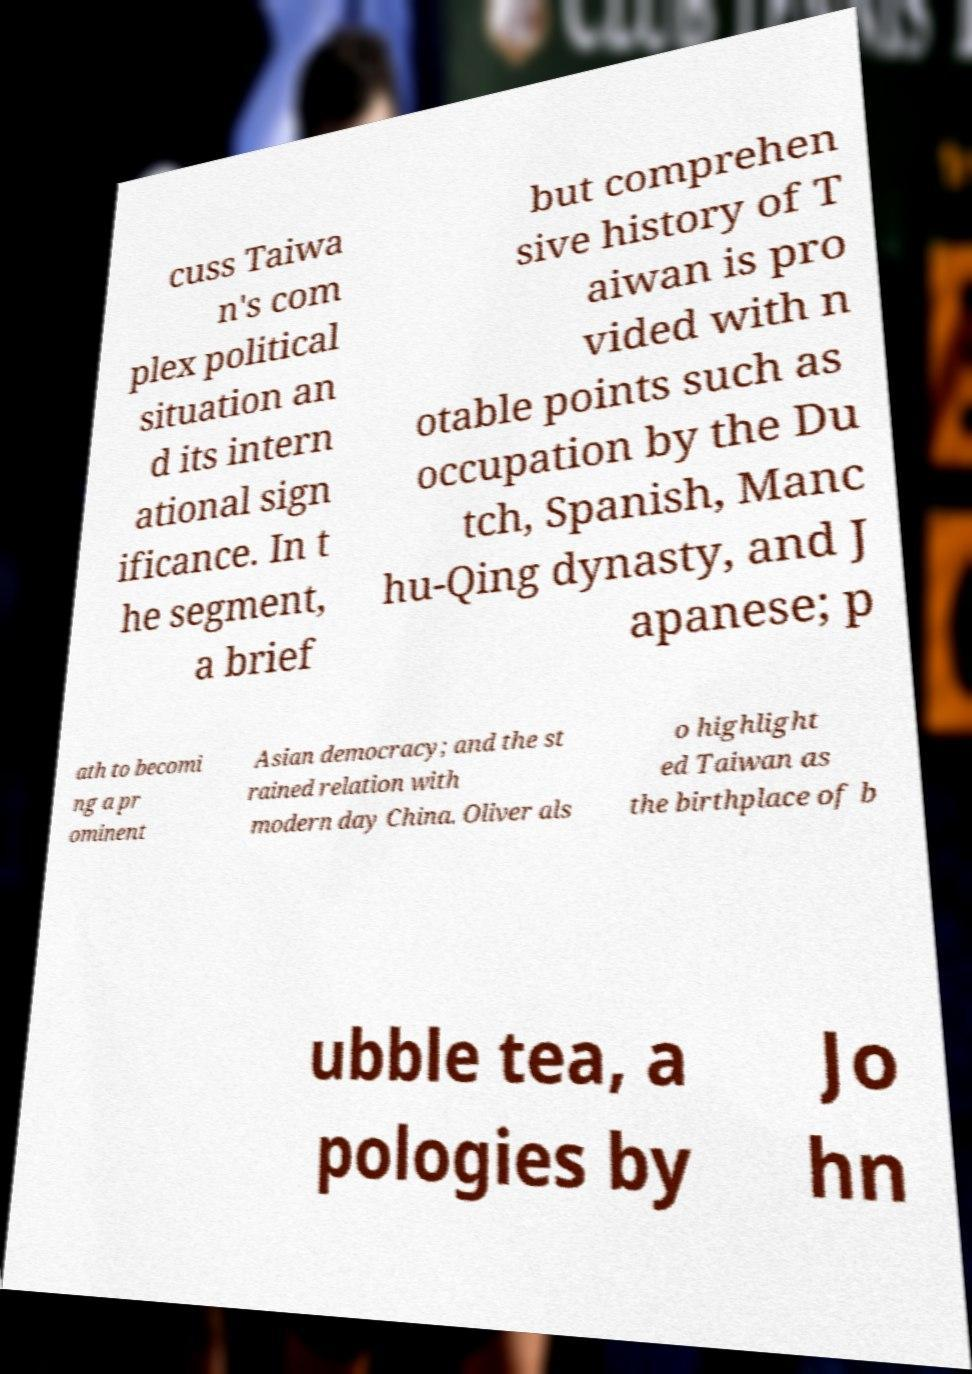Could you assist in decoding the text presented in this image and type it out clearly? cuss Taiwa n's com plex political situation an d its intern ational sign ificance. In t he segment, a brief but comprehen sive history of T aiwan is pro vided with n otable points such as occupation by the Du tch, Spanish, Manc hu-Qing dynasty, and J apanese; p ath to becomi ng a pr ominent Asian democracy; and the st rained relation with modern day China. Oliver als o highlight ed Taiwan as the birthplace of b ubble tea, a pologies by Jo hn 